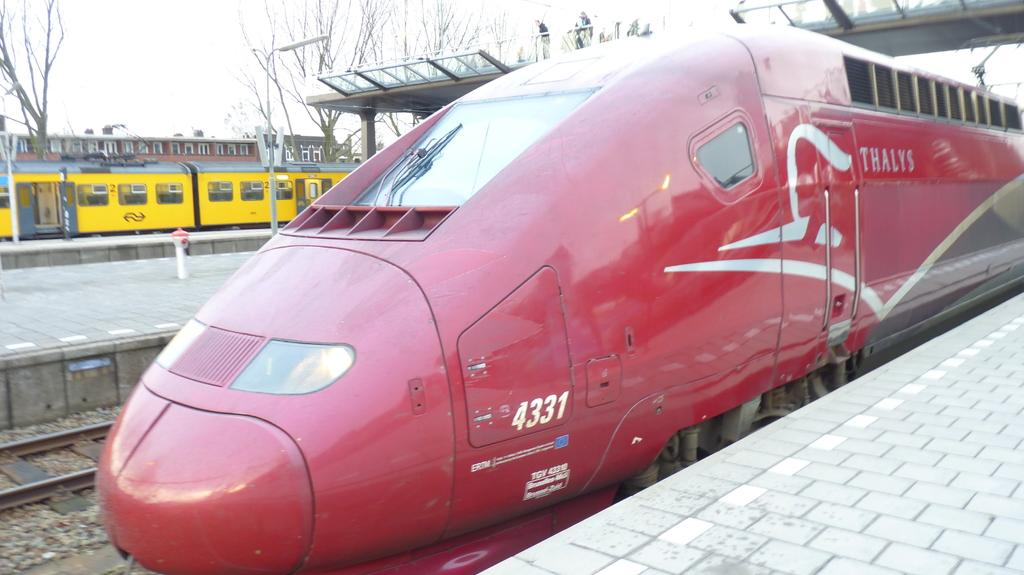What type of vehicles are present in the image? There are two trains in the image, a red train and a yellow train. Where are the trains located in the image? The trains are on different platforms in the image. What type of location is depicted in the image? The image depicts a railway station. How many swings can be seen in the image? There are no swings present in the image; it features a red train, a yellow train, and a railway station. 